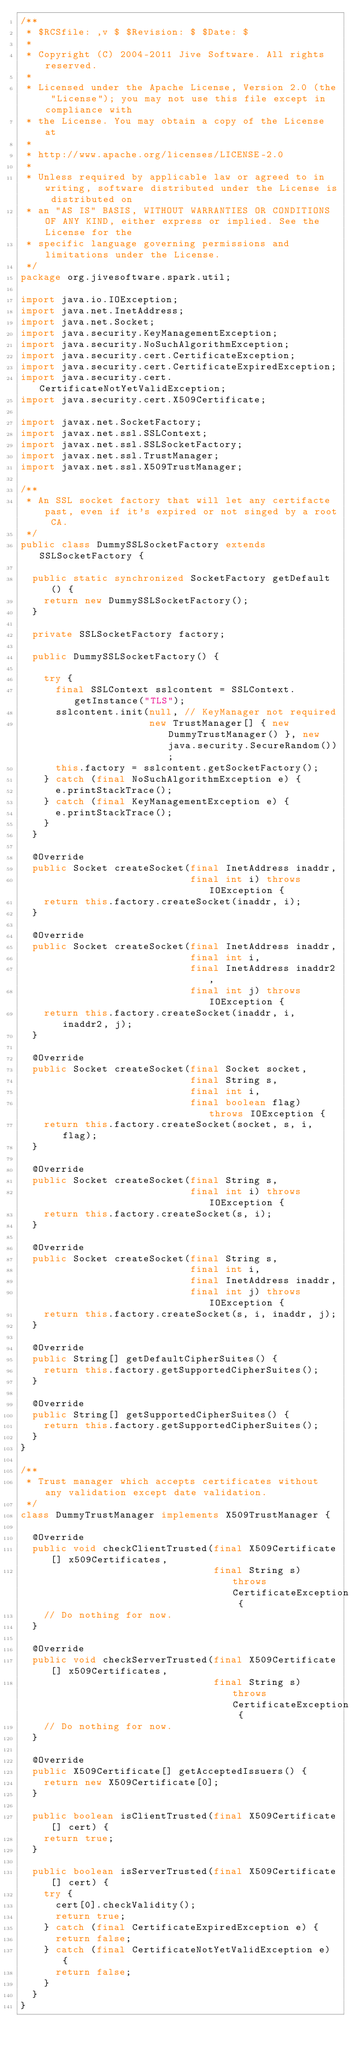Convert code to text. <code><loc_0><loc_0><loc_500><loc_500><_Java_>/**
 * $RCSfile: ,v $ $Revision: $ $Date: $
 * 
 * Copyright (C) 2004-2011 Jive Software. All rights reserved.
 * 
 * Licensed under the Apache License, Version 2.0 (the "License"); you may not use this file except in compliance with
 * the License. You may obtain a copy of the License at
 * 
 * http://www.apache.org/licenses/LICENSE-2.0
 * 
 * Unless required by applicable law or agreed to in writing, software distributed under the License is distributed on
 * an "AS IS" BASIS, WITHOUT WARRANTIES OR CONDITIONS OF ANY KIND, either express or implied. See the License for the
 * specific language governing permissions and limitations under the License.
 */
package org.jivesoftware.spark.util;

import java.io.IOException;
import java.net.InetAddress;
import java.net.Socket;
import java.security.KeyManagementException;
import java.security.NoSuchAlgorithmException;
import java.security.cert.CertificateException;
import java.security.cert.CertificateExpiredException;
import java.security.cert.CertificateNotYetValidException;
import java.security.cert.X509Certificate;

import javax.net.SocketFactory;
import javax.net.ssl.SSLContext;
import javax.net.ssl.SSLSocketFactory;
import javax.net.ssl.TrustManager;
import javax.net.ssl.X509TrustManager;

/**
 * An SSL socket factory that will let any certifacte past, even if it's expired or not singed by a root CA.
 */
public class DummySSLSocketFactory extends SSLSocketFactory {
	
	public static synchronized SocketFactory getDefault() {
		return new DummySSLSocketFactory();
	}
	
	private SSLSocketFactory factory;
	
	public DummySSLSocketFactory() {
		
		try {
			final SSLContext sslcontent = SSLContext.getInstance("TLS");
			sslcontent.init(null, // KeyManager not required
			                new TrustManager[] { new DummyTrustManager() }, new java.security.SecureRandom());
			this.factory = sslcontent.getSocketFactory();
		} catch (final NoSuchAlgorithmException e) {
			e.printStackTrace();
		} catch (final KeyManagementException e) {
			e.printStackTrace();
		}
	}
	
	@Override
	public Socket createSocket(final InetAddress inaddr,
	                           final int i) throws IOException {
		return this.factory.createSocket(inaddr, i);
	}
	
	@Override
	public Socket createSocket(final InetAddress inaddr,
	                           final int i,
	                           final InetAddress inaddr2,
	                           final int j) throws IOException {
		return this.factory.createSocket(inaddr, i, inaddr2, j);
	}
	
	@Override
	public Socket createSocket(final Socket socket,
	                           final String s,
	                           final int i,
	                           final boolean flag) throws IOException {
		return this.factory.createSocket(socket, s, i, flag);
	}
	
	@Override
	public Socket createSocket(final String s,
	                           final int i) throws IOException {
		return this.factory.createSocket(s, i);
	}
	
	@Override
	public Socket createSocket(final String s,
	                           final int i,
	                           final InetAddress inaddr,
	                           final int j) throws IOException {
		return this.factory.createSocket(s, i, inaddr, j);
	}
	
	@Override
	public String[] getDefaultCipherSuites() {
		return this.factory.getSupportedCipherSuites();
	}
	
	@Override
	public String[] getSupportedCipherSuites() {
		return this.factory.getSupportedCipherSuites();
	}
}

/**
 * Trust manager which accepts certificates without any validation except date validation.
 */
class DummyTrustManager implements X509TrustManager {
	
	@Override
	public void checkClientTrusted(final X509Certificate[] x509Certificates,
	                               final String s) throws CertificateException {
		// Do nothing for now.
	}
	
	@Override
	public void checkServerTrusted(final X509Certificate[] x509Certificates,
	                               final String s) throws CertificateException {
		// Do nothing for now.
	}
	
	@Override
	public X509Certificate[] getAcceptedIssuers() {
		return new X509Certificate[0];
	}
	
	public boolean isClientTrusted(final X509Certificate[] cert) {
		return true;
	}
	
	public boolean isServerTrusted(final X509Certificate[] cert) {
		try {
			cert[0].checkValidity();
			return true;
		} catch (final CertificateExpiredException e) {
			return false;
		} catch (final CertificateNotYetValidException e) {
			return false;
		}
	}
}
</code> 